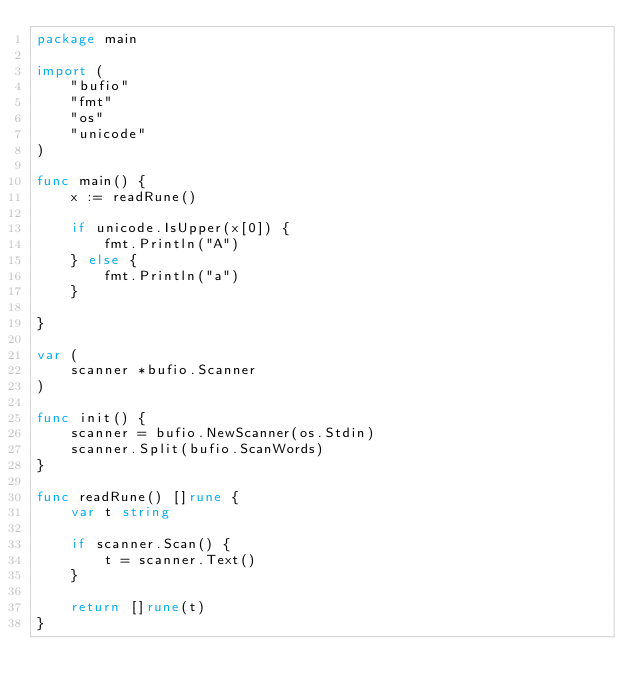<code> <loc_0><loc_0><loc_500><loc_500><_Go_>package main

import (
	"bufio"
	"fmt"
	"os"
	"unicode"
)

func main() {
	x := readRune()

	if unicode.IsUpper(x[0]) {
		fmt.Println("A")
	} else {
		fmt.Println("a")
	}

}

var (
	scanner *bufio.Scanner
)

func init() {
	scanner = bufio.NewScanner(os.Stdin)
	scanner.Split(bufio.ScanWords)
}

func readRune() []rune {
	var t string

	if scanner.Scan() {
		t = scanner.Text()
	}

	return []rune(t)
}
</code> 